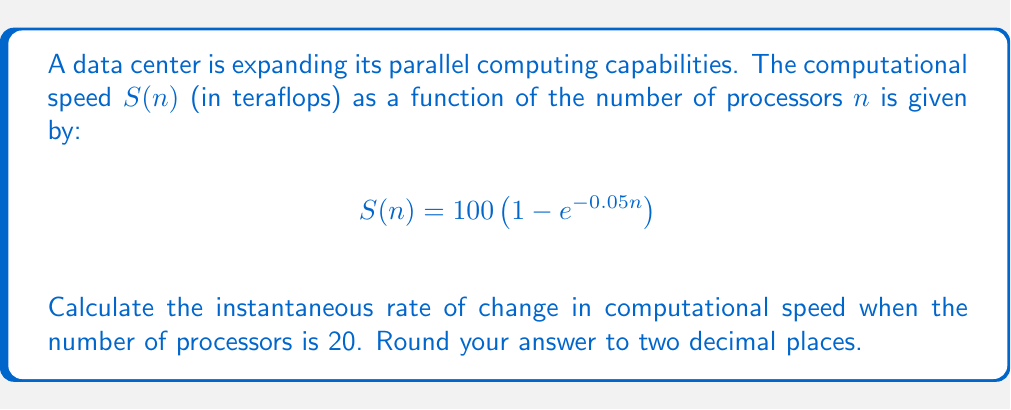Teach me how to tackle this problem. To solve this problem, we need to find the derivative of $S(n)$ with respect to $n$ and evaluate it at $n = 20$. This will give us the instantaneous rate of change.

1. First, let's find the derivative of $S(n)$:
   
   $$\frac{d}{dn}S(n) = \frac{d}{dn}\left[100 \left(1 - e^{-0.05n}\right)\right]$$
   
   Using the chain rule:
   
   $$\frac{d}{dn}S(n) = 100 \cdot \frac{d}{dn}\left[1 - e^{-0.05n}\right]$$
   
   $$\frac{d}{dn}S(n) = 100 \cdot \left[0 - (-0.05)e^{-0.05n}\right]$$
   
   $$\frac{d}{dn}S(n) = 5e^{-0.05n}$$

2. Now, we evaluate this derivative at $n = 20$:
   
   $$\left.\frac{d}{dn}S(n)\right|_{n=20} = 5e^{-0.05(20)}$$
   
   $$= 5e^{-1}$$
   
   $$\approx 1.8393$$

3. Rounding to two decimal places:
   
   $$1.84$$

This result represents the instantaneous rate of change in computational speed (in teraflops per processor) when there are 20 processors.
Answer: 1.84 teraflops per processor 